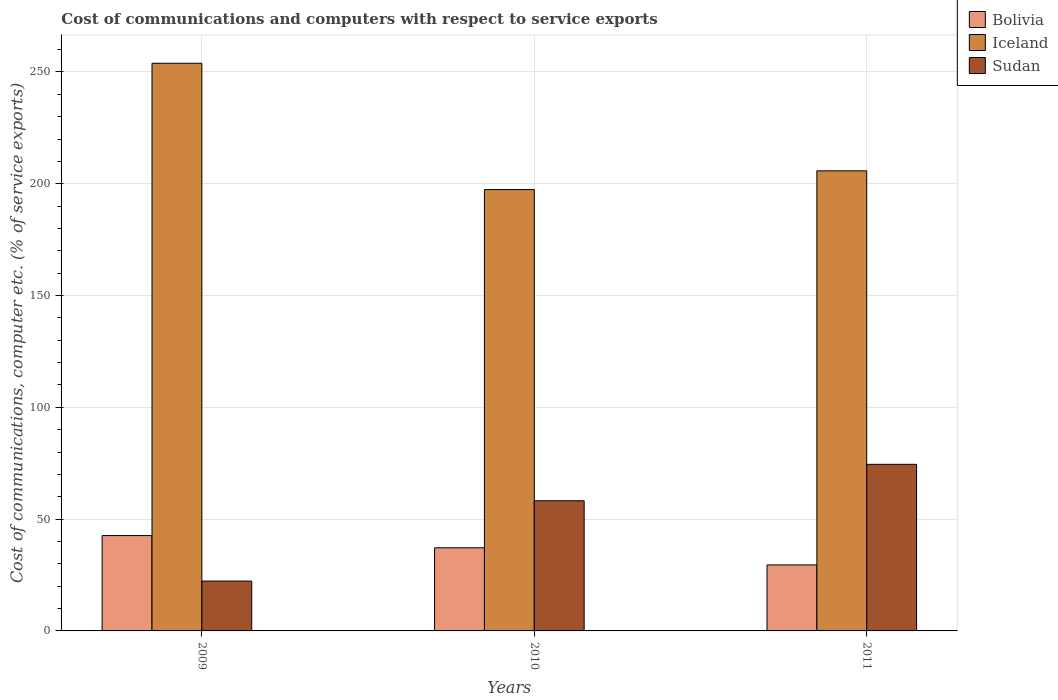How many different coloured bars are there?
Offer a terse response. 3. Are the number of bars per tick equal to the number of legend labels?
Provide a short and direct response. Yes. Are the number of bars on each tick of the X-axis equal?
Your response must be concise. Yes. How many bars are there on the 3rd tick from the right?
Offer a very short reply. 3. What is the label of the 2nd group of bars from the left?
Offer a terse response. 2010. In how many cases, is the number of bars for a given year not equal to the number of legend labels?
Make the answer very short. 0. What is the cost of communications and computers in Bolivia in 2009?
Provide a short and direct response. 42.65. Across all years, what is the maximum cost of communications and computers in Bolivia?
Offer a very short reply. 42.65. Across all years, what is the minimum cost of communications and computers in Bolivia?
Keep it short and to the point. 29.52. In which year was the cost of communications and computers in Bolivia maximum?
Provide a short and direct response. 2009. In which year was the cost of communications and computers in Sudan minimum?
Provide a succinct answer. 2009. What is the total cost of communications and computers in Sudan in the graph?
Your response must be concise. 155.02. What is the difference between the cost of communications and computers in Sudan in 2009 and that in 2011?
Offer a terse response. -52.22. What is the difference between the cost of communications and computers in Sudan in 2010 and the cost of communications and computers in Iceland in 2009?
Make the answer very short. -195.7. What is the average cost of communications and computers in Bolivia per year?
Give a very brief answer. 36.45. In the year 2009, what is the difference between the cost of communications and computers in Bolivia and cost of communications and computers in Sudan?
Give a very brief answer. 20.35. In how many years, is the cost of communications and computers in Iceland greater than 30 %?
Your response must be concise. 3. What is the ratio of the cost of communications and computers in Iceland in 2009 to that in 2010?
Offer a very short reply. 1.29. Is the cost of communications and computers in Bolivia in 2009 less than that in 2011?
Your answer should be very brief. No. What is the difference between the highest and the second highest cost of communications and computers in Bolivia?
Your response must be concise. 5.47. What is the difference between the highest and the lowest cost of communications and computers in Iceland?
Give a very brief answer. 56.51. In how many years, is the cost of communications and computers in Bolivia greater than the average cost of communications and computers in Bolivia taken over all years?
Your answer should be very brief. 2. Is the sum of the cost of communications and computers in Sudan in 2009 and 2010 greater than the maximum cost of communications and computers in Bolivia across all years?
Ensure brevity in your answer.  Yes. What does the 2nd bar from the left in 2011 represents?
Provide a succinct answer. Iceland. What does the 1st bar from the right in 2010 represents?
Keep it short and to the point. Sudan. Is it the case that in every year, the sum of the cost of communications and computers in Iceland and cost of communications and computers in Bolivia is greater than the cost of communications and computers in Sudan?
Offer a terse response. Yes. Are all the bars in the graph horizontal?
Your response must be concise. No. What is the difference between two consecutive major ticks on the Y-axis?
Offer a terse response. 50. Does the graph contain any zero values?
Provide a short and direct response. No. Does the graph contain grids?
Make the answer very short. Yes. How are the legend labels stacked?
Provide a short and direct response. Vertical. What is the title of the graph?
Keep it short and to the point. Cost of communications and computers with respect to service exports. Does "High income: nonOECD" appear as one of the legend labels in the graph?
Provide a succinct answer. No. What is the label or title of the X-axis?
Make the answer very short. Years. What is the label or title of the Y-axis?
Offer a terse response. Cost of communications, computer etc. (% of service exports). What is the Cost of communications, computer etc. (% of service exports) in Bolivia in 2009?
Make the answer very short. 42.65. What is the Cost of communications, computer etc. (% of service exports) in Iceland in 2009?
Make the answer very short. 253.9. What is the Cost of communications, computer etc. (% of service exports) in Sudan in 2009?
Provide a succinct answer. 22.3. What is the Cost of communications, computer etc. (% of service exports) in Bolivia in 2010?
Keep it short and to the point. 37.18. What is the Cost of communications, computer etc. (% of service exports) of Iceland in 2010?
Give a very brief answer. 197.4. What is the Cost of communications, computer etc. (% of service exports) of Sudan in 2010?
Your answer should be very brief. 58.2. What is the Cost of communications, computer etc. (% of service exports) of Bolivia in 2011?
Provide a short and direct response. 29.52. What is the Cost of communications, computer etc. (% of service exports) of Iceland in 2011?
Make the answer very short. 205.78. What is the Cost of communications, computer etc. (% of service exports) in Sudan in 2011?
Offer a very short reply. 74.52. Across all years, what is the maximum Cost of communications, computer etc. (% of service exports) of Bolivia?
Ensure brevity in your answer.  42.65. Across all years, what is the maximum Cost of communications, computer etc. (% of service exports) of Iceland?
Your answer should be compact. 253.9. Across all years, what is the maximum Cost of communications, computer etc. (% of service exports) in Sudan?
Your answer should be compact. 74.52. Across all years, what is the minimum Cost of communications, computer etc. (% of service exports) in Bolivia?
Your answer should be very brief. 29.52. Across all years, what is the minimum Cost of communications, computer etc. (% of service exports) of Iceland?
Provide a short and direct response. 197.4. Across all years, what is the minimum Cost of communications, computer etc. (% of service exports) of Sudan?
Your response must be concise. 22.3. What is the total Cost of communications, computer etc. (% of service exports) of Bolivia in the graph?
Your answer should be very brief. 109.35. What is the total Cost of communications, computer etc. (% of service exports) of Iceland in the graph?
Your answer should be very brief. 657.07. What is the total Cost of communications, computer etc. (% of service exports) of Sudan in the graph?
Give a very brief answer. 155.02. What is the difference between the Cost of communications, computer etc. (% of service exports) in Bolivia in 2009 and that in 2010?
Your answer should be very brief. 5.47. What is the difference between the Cost of communications, computer etc. (% of service exports) of Iceland in 2009 and that in 2010?
Offer a terse response. 56.51. What is the difference between the Cost of communications, computer etc. (% of service exports) in Sudan in 2009 and that in 2010?
Offer a terse response. -35.9. What is the difference between the Cost of communications, computer etc. (% of service exports) of Bolivia in 2009 and that in 2011?
Provide a short and direct response. 13.13. What is the difference between the Cost of communications, computer etc. (% of service exports) of Iceland in 2009 and that in 2011?
Give a very brief answer. 48.12. What is the difference between the Cost of communications, computer etc. (% of service exports) of Sudan in 2009 and that in 2011?
Ensure brevity in your answer.  -52.22. What is the difference between the Cost of communications, computer etc. (% of service exports) in Bolivia in 2010 and that in 2011?
Make the answer very short. 7.67. What is the difference between the Cost of communications, computer etc. (% of service exports) in Iceland in 2010 and that in 2011?
Offer a very short reply. -8.38. What is the difference between the Cost of communications, computer etc. (% of service exports) of Sudan in 2010 and that in 2011?
Your response must be concise. -16.31. What is the difference between the Cost of communications, computer etc. (% of service exports) in Bolivia in 2009 and the Cost of communications, computer etc. (% of service exports) in Iceland in 2010?
Offer a very short reply. -154.75. What is the difference between the Cost of communications, computer etc. (% of service exports) in Bolivia in 2009 and the Cost of communications, computer etc. (% of service exports) in Sudan in 2010?
Give a very brief answer. -15.56. What is the difference between the Cost of communications, computer etc. (% of service exports) of Iceland in 2009 and the Cost of communications, computer etc. (% of service exports) of Sudan in 2010?
Your answer should be very brief. 195.7. What is the difference between the Cost of communications, computer etc. (% of service exports) in Bolivia in 2009 and the Cost of communications, computer etc. (% of service exports) in Iceland in 2011?
Give a very brief answer. -163.13. What is the difference between the Cost of communications, computer etc. (% of service exports) in Bolivia in 2009 and the Cost of communications, computer etc. (% of service exports) in Sudan in 2011?
Offer a terse response. -31.87. What is the difference between the Cost of communications, computer etc. (% of service exports) in Iceland in 2009 and the Cost of communications, computer etc. (% of service exports) in Sudan in 2011?
Offer a terse response. 179.38. What is the difference between the Cost of communications, computer etc. (% of service exports) of Bolivia in 2010 and the Cost of communications, computer etc. (% of service exports) of Iceland in 2011?
Make the answer very short. -168.59. What is the difference between the Cost of communications, computer etc. (% of service exports) of Bolivia in 2010 and the Cost of communications, computer etc. (% of service exports) of Sudan in 2011?
Offer a very short reply. -37.33. What is the difference between the Cost of communications, computer etc. (% of service exports) in Iceland in 2010 and the Cost of communications, computer etc. (% of service exports) in Sudan in 2011?
Give a very brief answer. 122.88. What is the average Cost of communications, computer etc. (% of service exports) in Bolivia per year?
Offer a very short reply. 36.45. What is the average Cost of communications, computer etc. (% of service exports) in Iceland per year?
Your answer should be compact. 219.02. What is the average Cost of communications, computer etc. (% of service exports) in Sudan per year?
Provide a short and direct response. 51.67. In the year 2009, what is the difference between the Cost of communications, computer etc. (% of service exports) in Bolivia and Cost of communications, computer etc. (% of service exports) in Iceland?
Make the answer very short. -211.25. In the year 2009, what is the difference between the Cost of communications, computer etc. (% of service exports) of Bolivia and Cost of communications, computer etc. (% of service exports) of Sudan?
Provide a succinct answer. 20.35. In the year 2009, what is the difference between the Cost of communications, computer etc. (% of service exports) of Iceland and Cost of communications, computer etc. (% of service exports) of Sudan?
Offer a terse response. 231.6. In the year 2010, what is the difference between the Cost of communications, computer etc. (% of service exports) in Bolivia and Cost of communications, computer etc. (% of service exports) in Iceland?
Your answer should be very brief. -160.21. In the year 2010, what is the difference between the Cost of communications, computer etc. (% of service exports) of Bolivia and Cost of communications, computer etc. (% of service exports) of Sudan?
Your response must be concise. -21.02. In the year 2010, what is the difference between the Cost of communications, computer etc. (% of service exports) of Iceland and Cost of communications, computer etc. (% of service exports) of Sudan?
Make the answer very short. 139.19. In the year 2011, what is the difference between the Cost of communications, computer etc. (% of service exports) in Bolivia and Cost of communications, computer etc. (% of service exports) in Iceland?
Provide a succinct answer. -176.26. In the year 2011, what is the difference between the Cost of communications, computer etc. (% of service exports) in Bolivia and Cost of communications, computer etc. (% of service exports) in Sudan?
Ensure brevity in your answer.  -45. In the year 2011, what is the difference between the Cost of communications, computer etc. (% of service exports) of Iceland and Cost of communications, computer etc. (% of service exports) of Sudan?
Keep it short and to the point. 131.26. What is the ratio of the Cost of communications, computer etc. (% of service exports) of Bolivia in 2009 to that in 2010?
Offer a very short reply. 1.15. What is the ratio of the Cost of communications, computer etc. (% of service exports) of Iceland in 2009 to that in 2010?
Provide a short and direct response. 1.29. What is the ratio of the Cost of communications, computer etc. (% of service exports) of Sudan in 2009 to that in 2010?
Your response must be concise. 0.38. What is the ratio of the Cost of communications, computer etc. (% of service exports) in Bolivia in 2009 to that in 2011?
Make the answer very short. 1.45. What is the ratio of the Cost of communications, computer etc. (% of service exports) of Iceland in 2009 to that in 2011?
Keep it short and to the point. 1.23. What is the ratio of the Cost of communications, computer etc. (% of service exports) in Sudan in 2009 to that in 2011?
Your answer should be very brief. 0.3. What is the ratio of the Cost of communications, computer etc. (% of service exports) in Bolivia in 2010 to that in 2011?
Keep it short and to the point. 1.26. What is the ratio of the Cost of communications, computer etc. (% of service exports) in Iceland in 2010 to that in 2011?
Your response must be concise. 0.96. What is the ratio of the Cost of communications, computer etc. (% of service exports) in Sudan in 2010 to that in 2011?
Ensure brevity in your answer.  0.78. What is the difference between the highest and the second highest Cost of communications, computer etc. (% of service exports) in Bolivia?
Your response must be concise. 5.47. What is the difference between the highest and the second highest Cost of communications, computer etc. (% of service exports) in Iceland?
Your answer should be very brief. 48.12. What is the difference between the highest and the second highest Cost of communications, computer etc. (% of service exports) in Sudan?
Your response must be concise. 16.31. What is the difference between the highest and the lowest Cost of communications, computer etc. (% of service exports) in Bolivia?
Offer a very short reply. 13.13. What is the difference between the highest and the lowest Cost of communications, computer etc. (% of service exports) in Iceland?
Your response must be concise. 56.51. What is the difference between the highest and the lowest Cost of communications, computer etc. (% of service exports) in Sudan?
Make the answer very short. 52.22. 